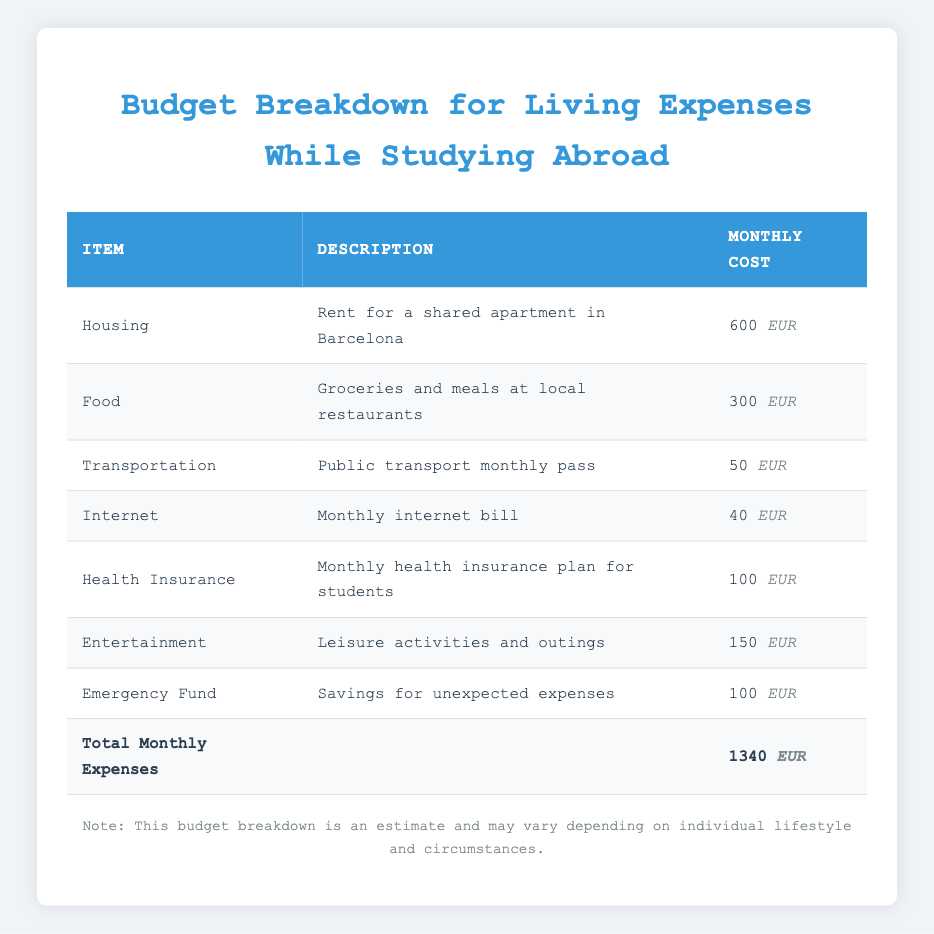What is the monthly cost for housing? The table specifies the monthly cost for housing. It lists "Housing" under the Item column with a "Monthly Cost" of 600 EUR.
Answer: 600 EUR What item has the lowest monthly cost? To find the item with the lowest monthly cost, we compare the monthly costs from each row. The costs are: Housing (600), Food (300), Transportation (50), Internet (40), Health Insurance (100), Entertainment (150), and Emergency Fund (100). The lowest is Transportation at 50 EUR.
Answer: Transportation Is the total monthly expense more than 1300 EUR? The total monthly expense is explicitly stated in the table as 1340 EUR, which is indeed more than 1300 EUR.
Answer: Yes Calculate the total cost of food and entertainment. The monthly cost of Food is 300 EUR and Entertainment is 150 EUR. Adding these two amounts together gives us a total of 300 + 150 = 450 EUR.
Answer: 450 EUR What percentage of the total monthly expenses is allocated to internet costs? First, determine the monthly cost for internet, which is 40 EUR. Then calculate the percentage of total expenses (1340 EUR) this cost represents. The formula is (40 / 1340) * 100. This equates to approximately 2.99%.
Answer: 2.99% What is the combined monthly cost of health insurance and emergency fund? The monthly cost for Health Insurance is 100 EUR, and for the Emergency Fund, it is also 100 EUR. By adding these two together (100 + 100), the total is 200 EUR.
Answer: 200 EUR Is the cost for food higher than the cost for internet? The table shows that the cost for Food is 300 EUR and for Internet is 40 EUR. Comparing these values, 300 EUR is greater than 40 EUR.
Answer: Yes If you add the costs for transportation, internet, and health insurance, what is the total? The costs listed are Transportation (50 EUR), Internet (40 EUR), and Health Insurance (100 EUR). Adding these amounts together: 50 + 40 + 100 = 190 EUR.
Answer: 190 EUR Is the combined cost of housing and food less than 1000 EUR? The cost of Housing is 600 EUR and Food is 300 EUR. Their combined cost is 600 + 300 = 900 EUR, which is less than 1000 EUR.
Answer: Yes 